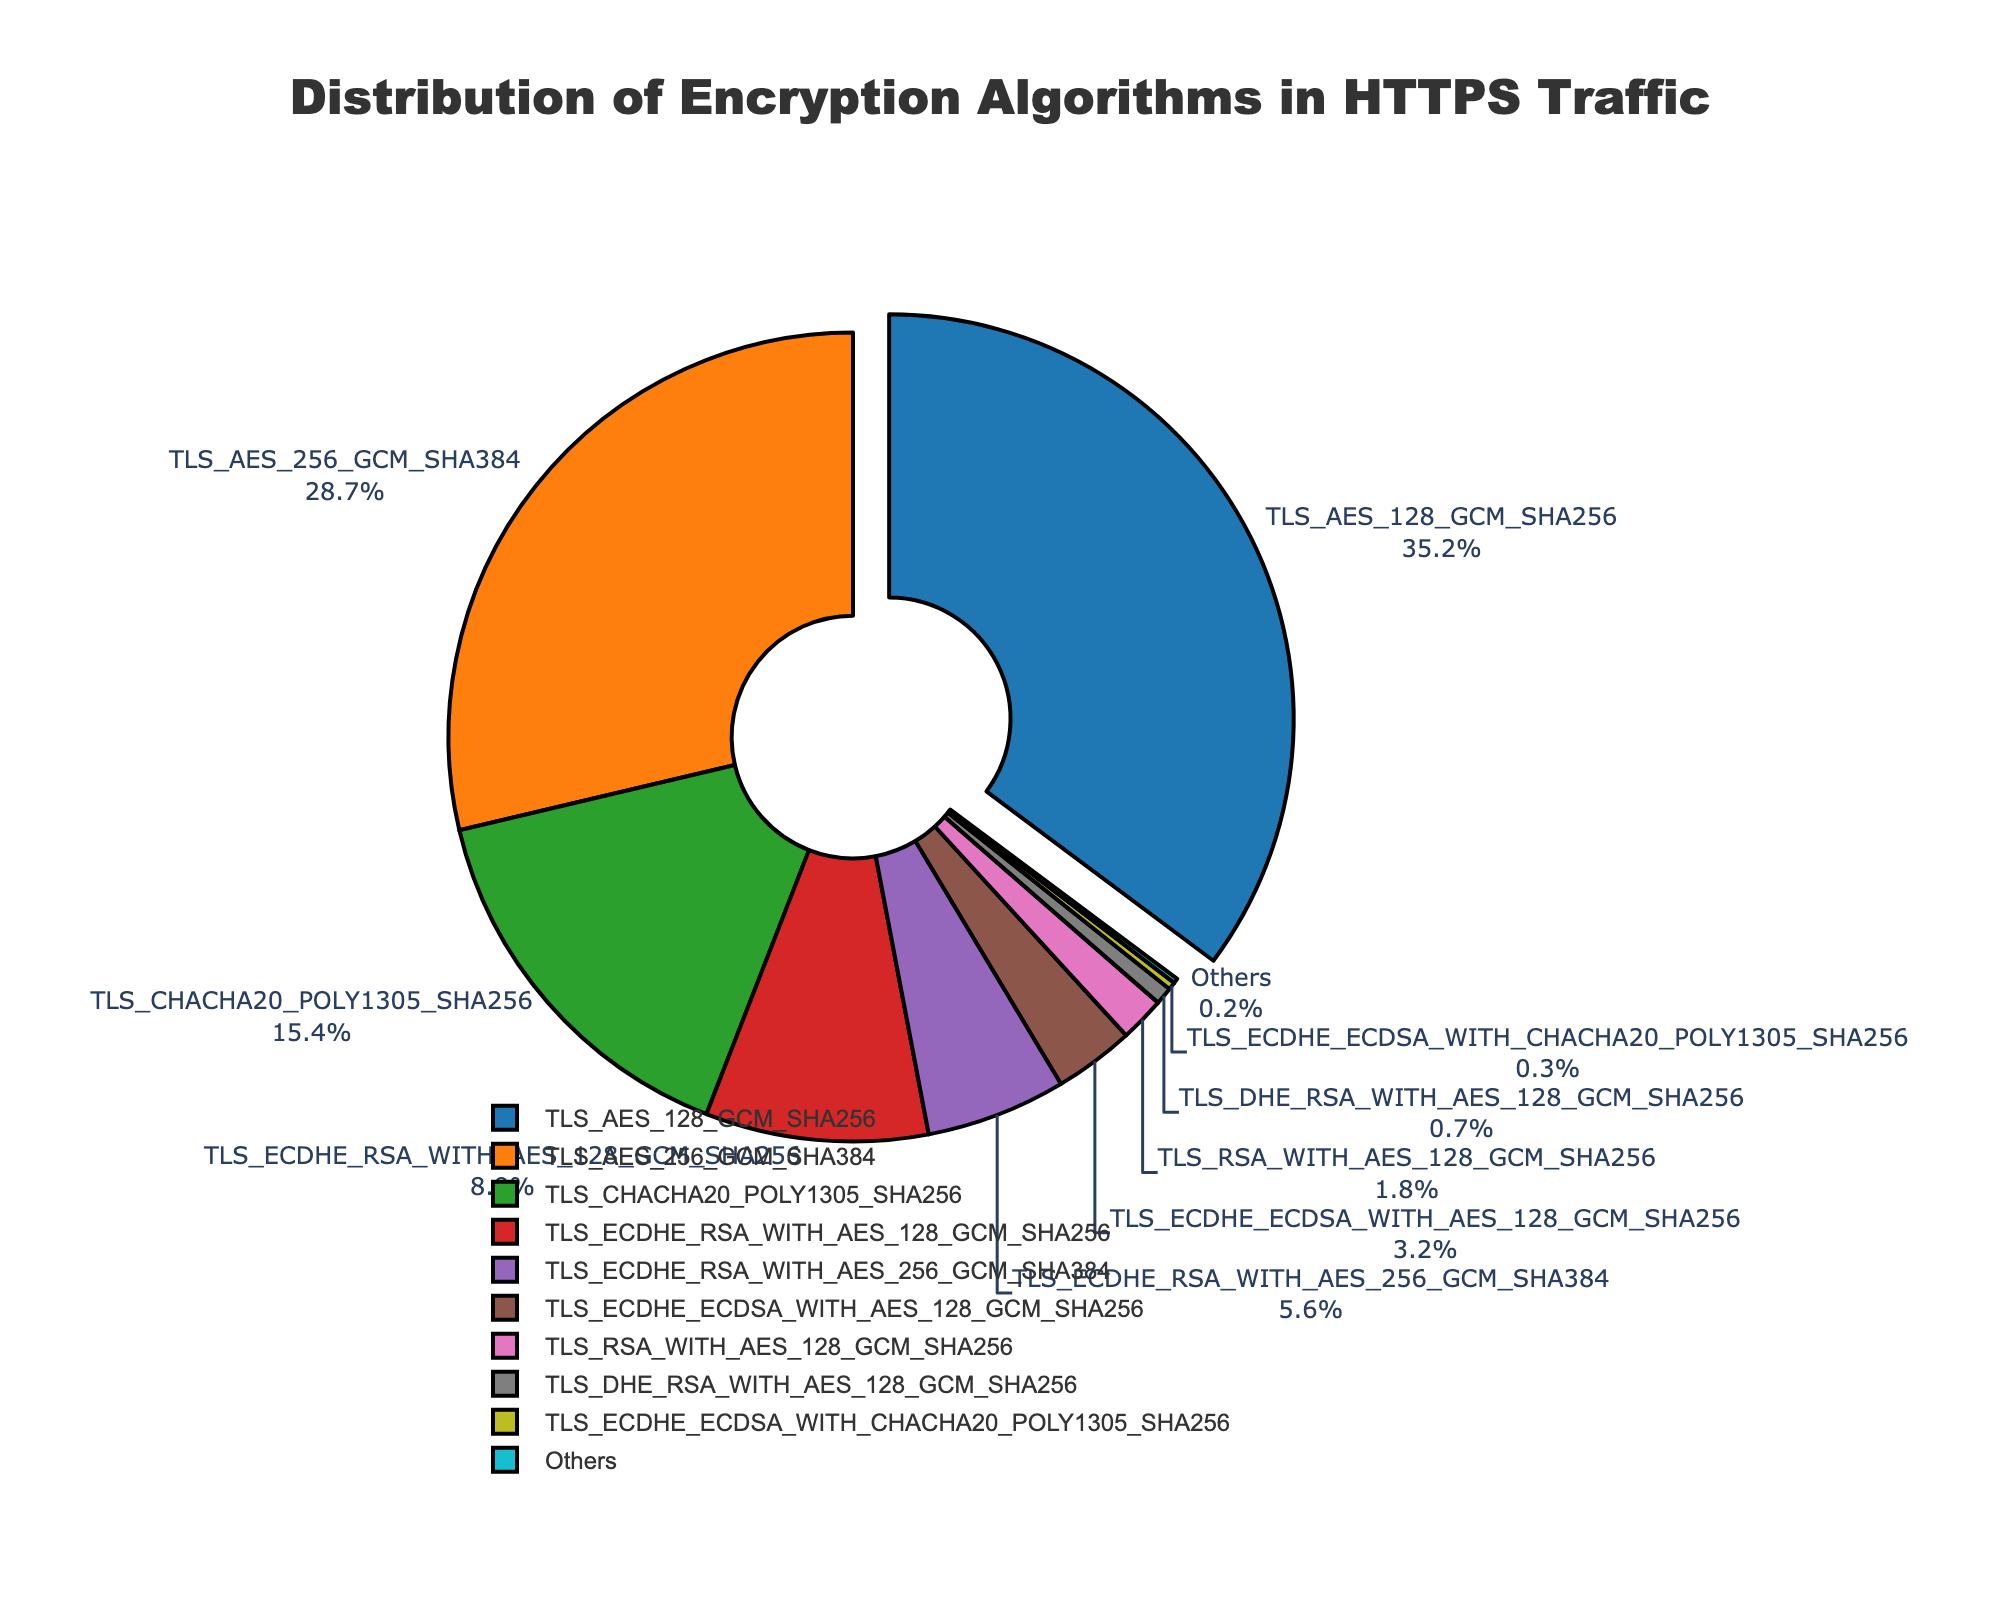Which algorithm has the highest usage percentage in HTTPS traffic? The algorithm with the largest portion of the pie chart and highest percentage label is TLS_AES_128_GCM_SHA256 with 35.2%.
Answer: TLS_AES_128_GCM_SHA256 What is the combined usage percentage of TLS_AES_128_GCM_SHA256 and TLS_AES_256_GCM_SHA384? Adding the percentages for TLS_AES_128_GCM_SHA256 (35.2%) and TLS_AES_256_GCM_SHA384 (28.7%) results in 35.2% + 28.7% = 63.9%.
Answer: 63.9% How does the usage of TLS_CHACHA20_POLY1305_SHA256 compare to TLS_ECDHE_RSA_WITH_AES_256_GCM_SHA384? TLS_CHACHA20_POLY1305_SHA256 has a higher percentage (15.4%) compared to TLS_ECDHE_RSA_WITH_AES_256_GCM_SHA384 (5.6%).
Answer: TLS_CHACHA20_POLY1305_SHA256 What is the least used algorithm in the provided data? The smallest portion of the pie chart represents "Others" with a percentage of 0.2%.
Answer: Others What fraction of HTTPS traffic uses either RSA or DHE-based algorithms? Summing the percentages of algorithms containing RSA or DHE results in 8.9% (TLS_ECDHE_RSA_WITH_AES_128_GCM_SHA256) + 5.6% (TLS_ECDHE_RSA_WITH_AES_256_GCM_SHA384) + 1.8% (TLS_RSA_WITH_AES_128_GCM_SHA256) + 0.7% (TLS_DHE_RSA_WITH_AES_128_GCM_SHA256) = 17%.
Answer: 17% Which algorithm has the second highest usage percentage? The second largest portion of the pie chart is for TLS_AES_256_GCM_SHA384 with 28.7%.
Answer: TLS_AES_256_GCM_SHA384 How much more usage does the most used algorithm have compared to the least used algorithm? The most used algorithm TLS_AES_128_GCM_SHA256 has 35.2%, and the least used algorithm "Others" has 0.2%. The difference is 35.2% - 0.2% = 35%.
Answer: 35% What portion of algorithms use AES_256 over AES_128? Summing the percentages of algorithms that use AES_256: TLS_AES_256_GCM_SHA384 (28.7%) + TLS_ECDHE_RSA_WITH_AES_256_GCM_SHA384 (5.6%) results in 28.7% + 5.6% = 34.3%.
Answer: 34.3% How many times more is the usage of TLS_AES_128_GCM_SHA256 compared to TLS_DHE_RSA_WITH_AES_128_GCM_SHA256? Dividing the percentage of TLS_AES_128_GCM_SHA256 (35.2%) by TLS_DHE_RSA_WITH_AES_128_GCM_SHA256 (0.7%), we get 35.2 / 0.7 ≈ 50.3 times.
Answer: 50.3 times What is the difference in percentage between the two least used specific algorithms? The two least used specific algorithms are TLS_ECDHE_ECDSA_WITH_CHACHA20_POLY1305_SHA256 (0.3%) and TLS_DHE_RSA_WITH_AES_128_GCM_SHA256 (0.7%). The difference is 0.7% - 0.3% = 0.4%.
Answer: 0.4% 